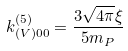<formula> <loc_0><loc_0><loc_500><loc_500>k _ { ( V ) 0 0 } ^ { ( 5 ) } = \frac { 3 \sqrt { 4 \pi } \xi } { 5 m _ { P } }</formula> 